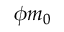Convert formula to latex. <formula><loc_0><loc_0><loc_500><loc_500>\phi m _ { 0 }</formula> 